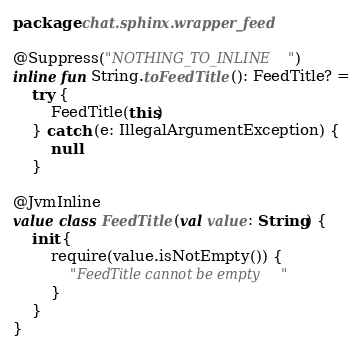Convert code to text. <code><loc_0><loc_0><loc_500><loc_500><_Kotlin_>package chat.sphinx.wrapper_feed

@Suppress("NOTHING_TO_INLINE")
inline fun String.toFeedTitle(): FeedTitle? =
    try {
        FeedTitle(this)
    } catch (e: IllegalArgumentException) {
        null
    }

@JvmInline
value class FeedTitle(val value: String) {
    init {
        require(value.isNotEmpty()) {
            "FeedTitle cannot be empty"
        }
    }
}</code> 